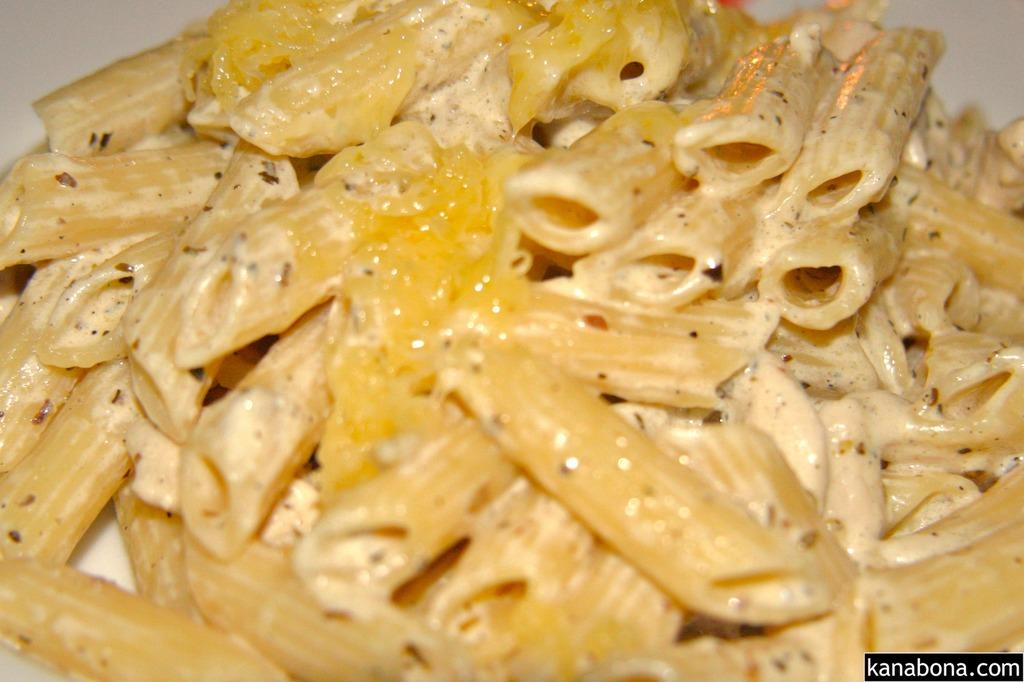What type of food is visible in the image? There is pasta in the image. Is there any text present in the image? Yes, there is some text at the right bottom of the image. How many eggs are being carried by the farmer in the image? There is no farmer or eggs present in the image. 